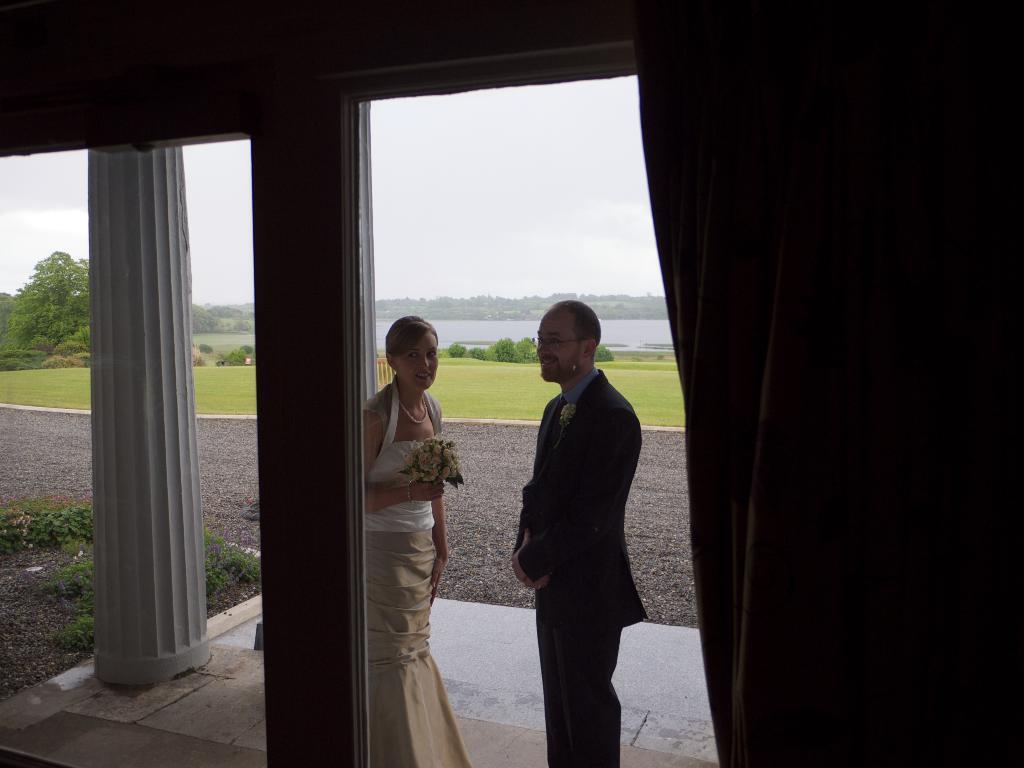Please provide a concise description of this image. In the image we can see a man and a woman standing, wearing clothes and the woman is holding a flower bookey in her hand. Here we can see pillar, grass, trees, water and the sky. The right part of the image is dark. 